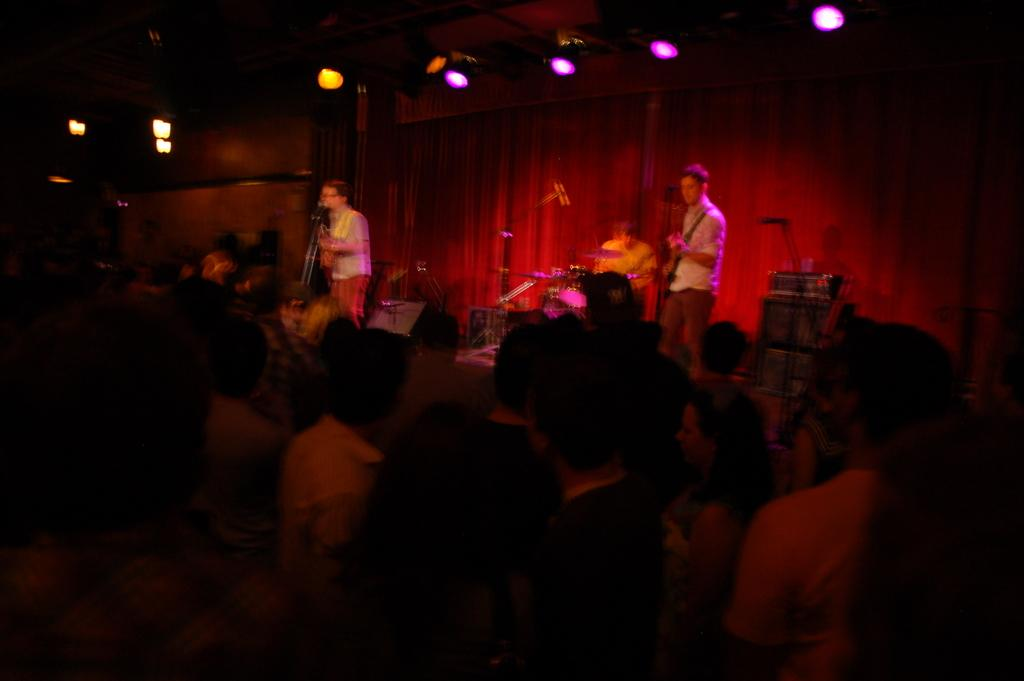How many people are playing musical instruments in the image? There are two men in the image, and they are both playing guitars. What are the men standing on in the image? The men are standing on a dais in the image. What can be seen at the bottom of the image? There is a crowd at the bottom of the image. What is visible in the background of the image? There is a curtain and lights in the background of the image. What type of cloud can be seen in the image? There are no clouds visible in the image; it features two men playing guitars on a dais with a crowd and a curtain in the background. 